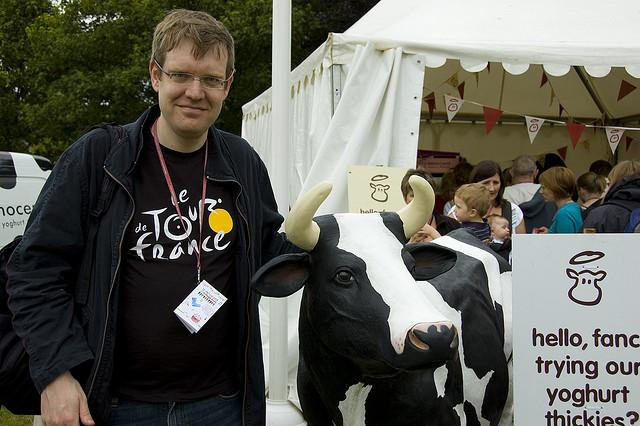What type of industry is being represented?

Choices:
A) dairy
B) clothing
C) gun
D) oil dairy 